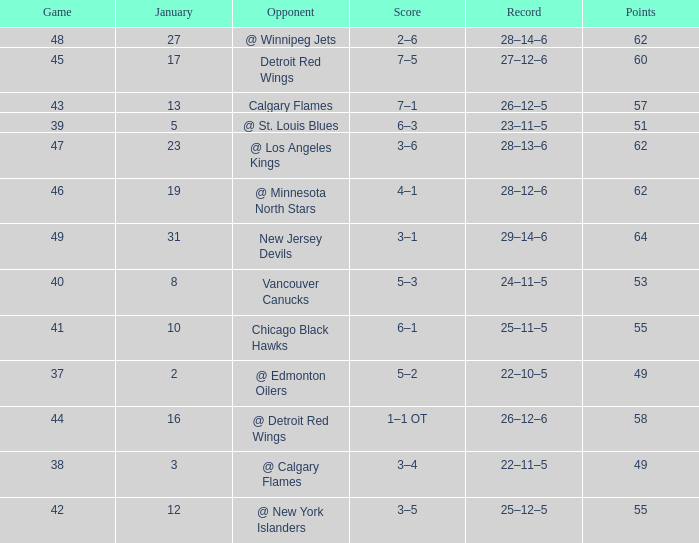How much January has a Record of 26–12–6, and Points smaller than 58? None. 